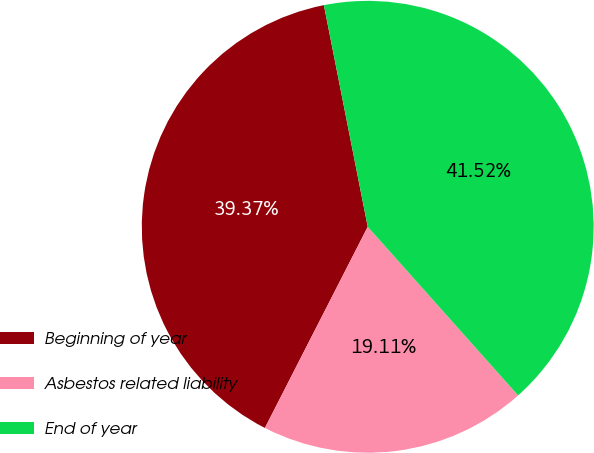Convert chart to OTSL. <chart><loc_0><loc_0><loc_500><loc_500><pie_chart><fcel>Beginning of year<fcel>Asbestos related liability<fcel>End of year<nl><fcel>39.37%<fcel>19.11%<fcel>41.52%<nl></chart> 